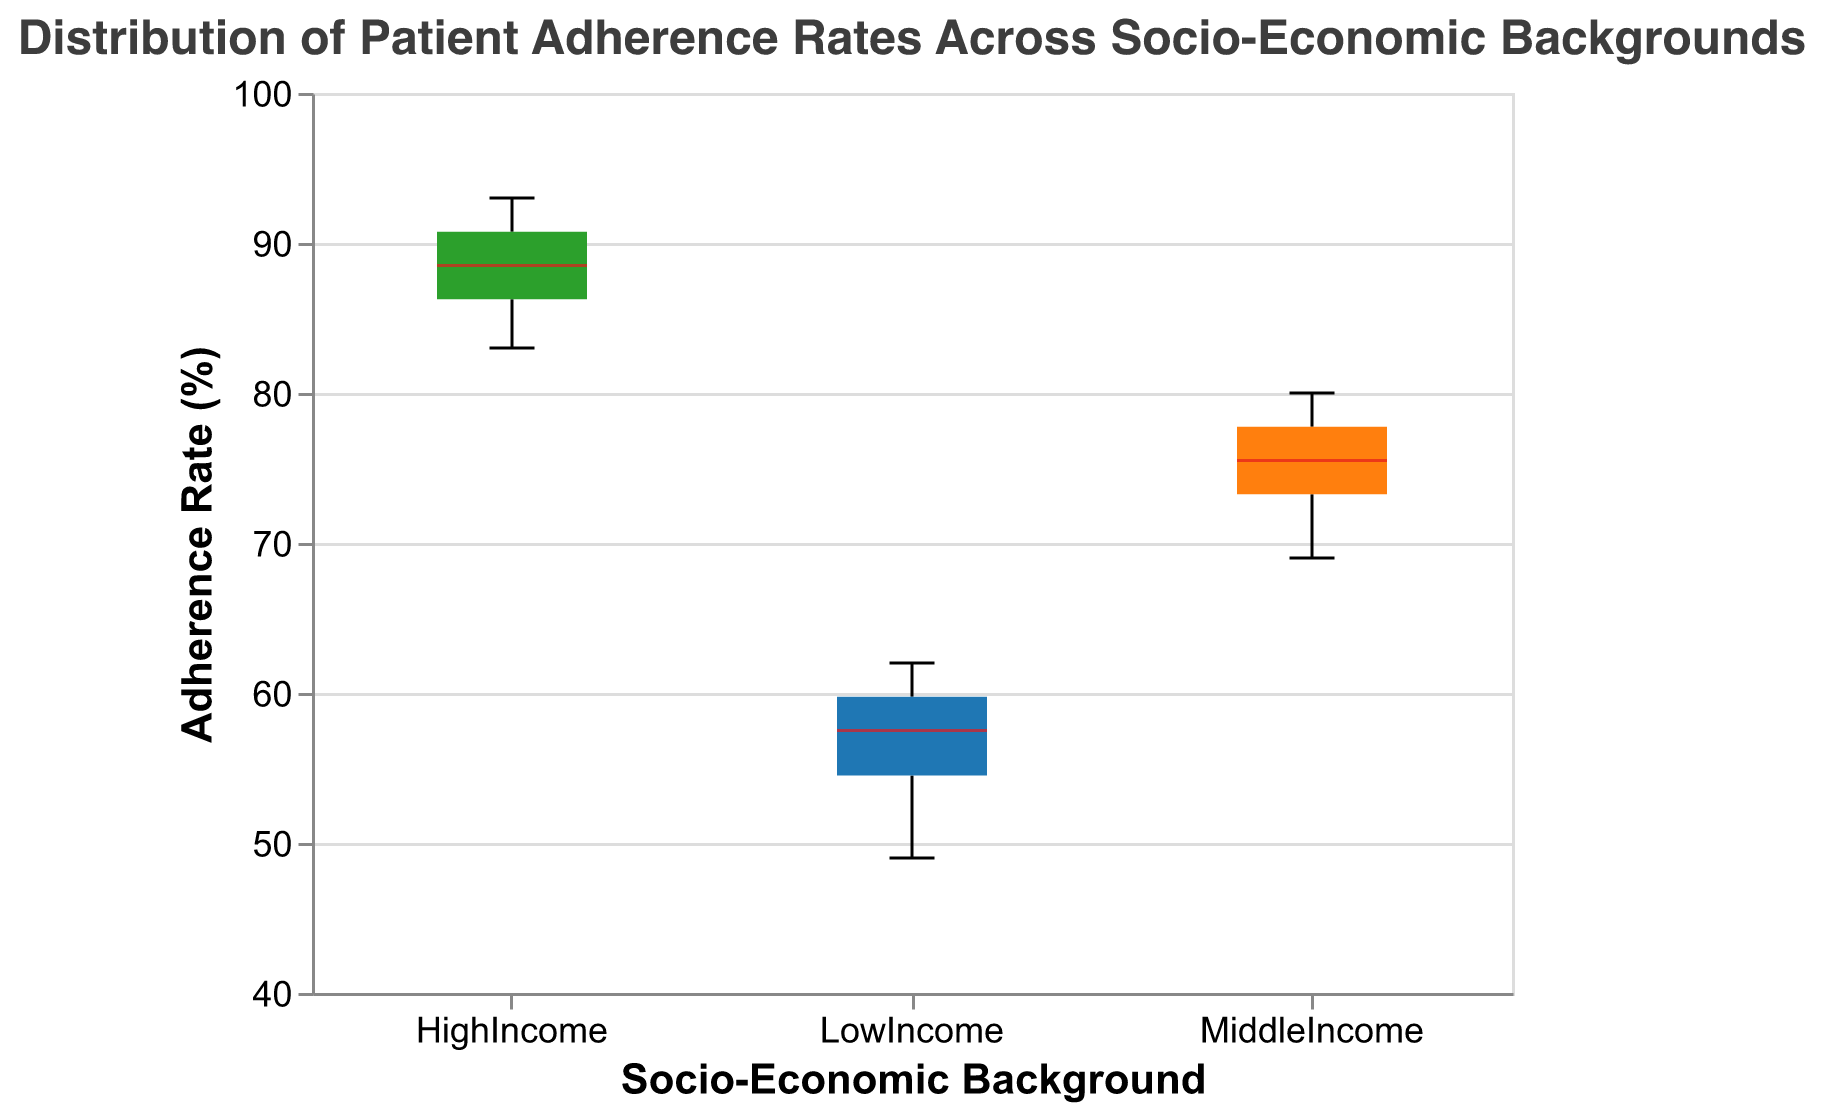What is the title of the figure? The title of the figure is "Distribution of Patient Adherence Rates Across Socio-Economic Backgrounds." This information is usually found at the top of the chart.
Answer: Distribution of Patient Adherence Rates Across Socio-Economic Backgrounds What are the socio-economic backgrounds considered in the figure? The socio-economic backgrounds considered in the figure are represented along the x-axis. They include "LowIncome," "MiddleIncome," and "HighIncome."
Answer: LowIncome, MiddleIncome, HighIncome Which socio-economic background group has the highest median adherence rate? To determine which group has the highest median adherence rate, look for the group whose boxplot has the median line (often colored differently) at the highest position on the y-axis. For this figure, it is the "HighIncome" group.
Answer: HighIncome What is the range of adherence rates for the MiddleIncome group? The range represents the minimum and maximum values for the adherence rates in the MiddleIncome group. This can be assessed by observing the lower and upper whiskers of the MiddleIncome box plot. From the figure, the range is 69% to 80%.
Answer: 69% to 80% Compare the interquartile ranges (IQR) of the LowIncome and HighIncome groups. Which group has a larger IQR? The interquartile range (IQR) is the difference between the third quartile (Q3) and the first quartile (Q1) values. By observing the box lengths, it is clear that the LowIncome group has a shorter box compared to the HighIncome group. Therefore, the HighIncome group has a larger IQR.
Answer: HighIncome For which group is the variability in adherence rates the lowest? The variability in adherence rates can be inferred from the spread of the data, as represented by the total length of the whiskers and the size of the box (IQR). The LowIncome group shows the least spread in its box plot, indicating the lowest variability.
Answer: LowIncome What is the median adherence rate for the LowIncome group? The median adherence rate for each group is denoted by the line inside the box of its box plot. For the LowIncome group, this median line intersects the y-axis at approximately 57%.
Answer: 57% Are there any outliers in the data, according to the box plots? Outliers in a box plot are typically represented by individual points outside the whiskers. In this figure, there are no points outside the whiskers, indicating no outliers.
Answer: No How does the median adherence rate of the MiddleIncome group compare to that of the HighIncome group? By comparing the median lines in the boxes of the MiddleIncome and HighIncome groups, it is clear that the median of the HighIncome group is higher than that of the MiddleIncome group. The median for the MiddleIncome group is at approximately 75%, while for the HighIncome group, it is around 88%.
Answer: Higher Between which adherence rates does the middle 50% of the LowIncome group data fall? The middle 50% of the data falls within the box of the box plot, which represents the interquartile range (IQR). For the LowIncome group, this range is approximately from 54% to 60%.
Answer: 54% to 60% 